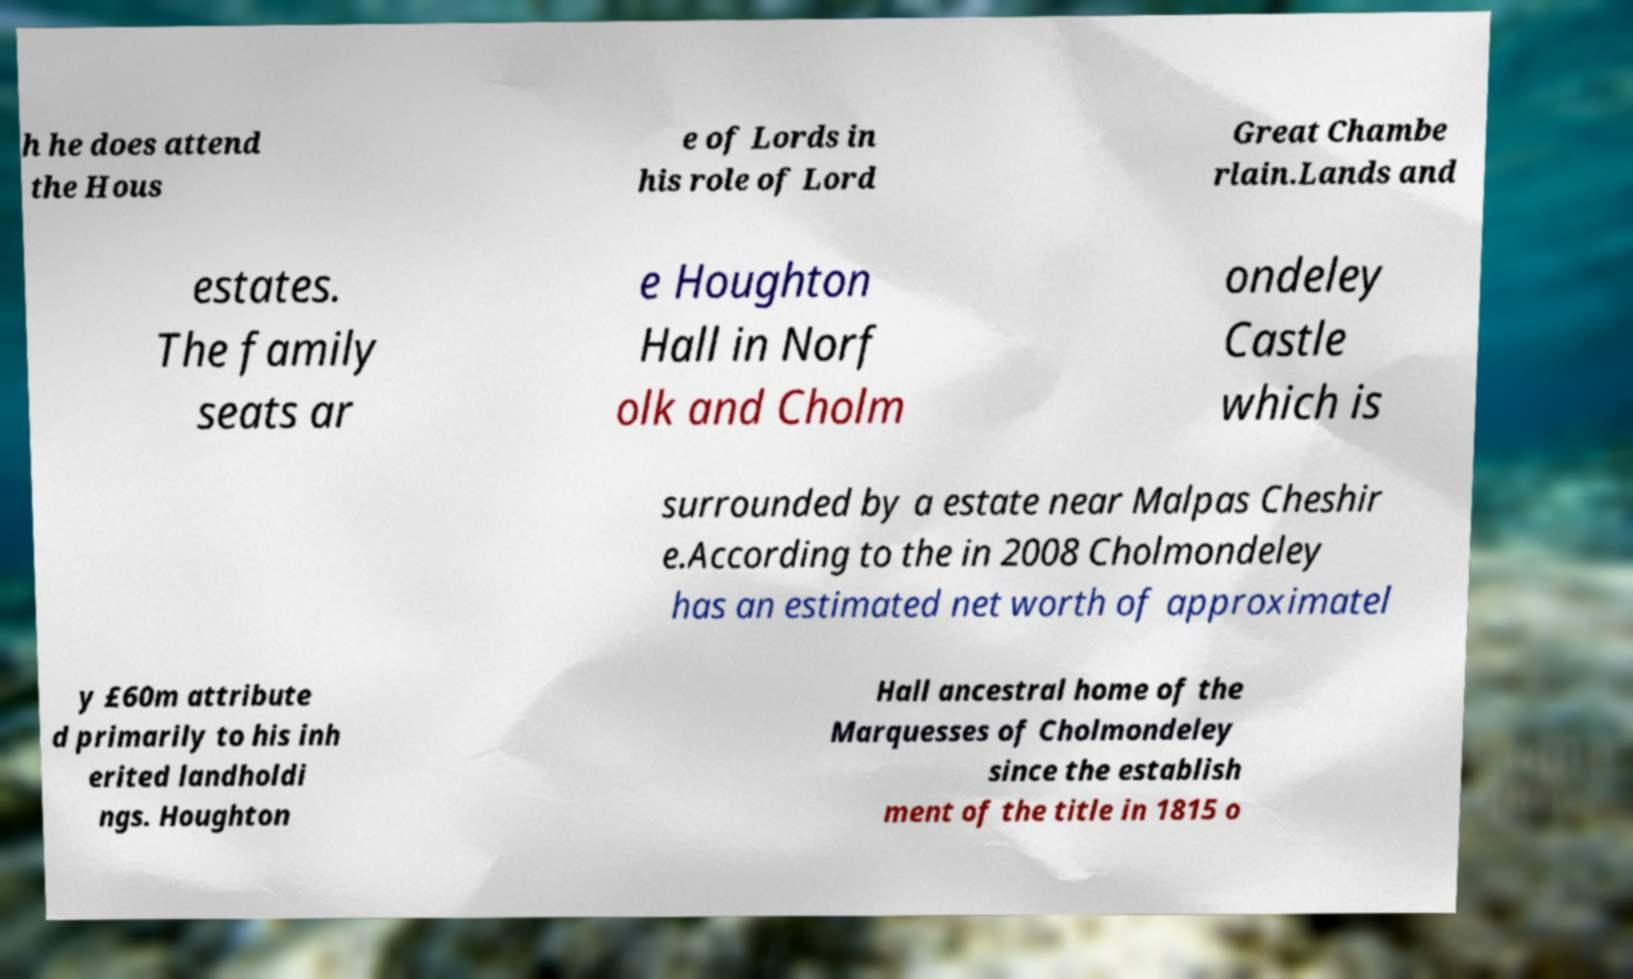There's text embedded in this image that I need extracted. Can you transcribe it verbatim? h he does attend the Hous e of Lords in his role of Lord Great Chambe rlain.Lands and estates. The family seats ar e Houghton Hall in Norf olk and Cholm ondeley Castle which is surrounded by a estate near Malpas Cheshir e.According to the in 2008 Cholmondeley has an estimated net worth of approximatel y £60m attribute d primarily to his inh erited landholdi ngs. Houghton Hall ancestral home of the Marquesses of Cholmondeley since the establish ment of the title in 1815 o 